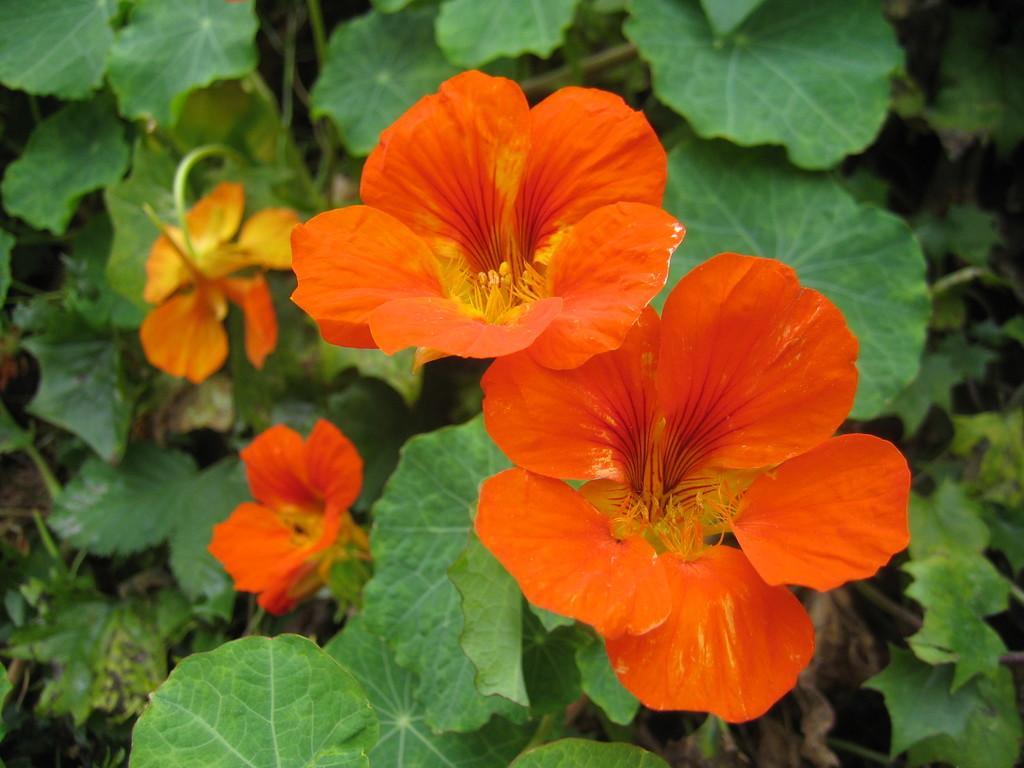Can you describe this image briefly? In this image we can see some flowers to a plant. 